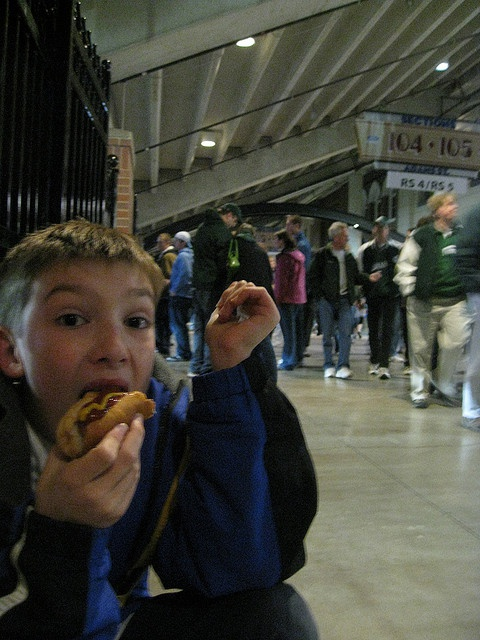Describe the objects in this image and their specific colors. I can see people in black, maroon, and gray tones, people in black, gray, and darkgray tones, people in black, gray, and darkblue tones, people in black, gray, blue, and darkgreen tones, and people in black, gray, darkgray, and darkgreen tones in this image. 